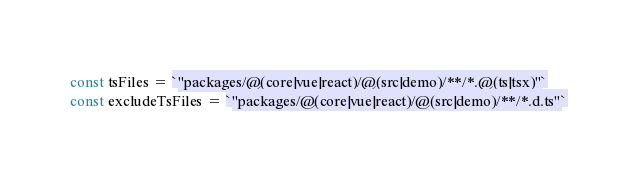<code> <loc_0><loc_0><loc_500><loc_500><_TypeScript_>const tsFiles = `"packages/@(core|vue|react)/@(src|demo)/**/*.@(ts|tsx)"`
const excludeTsFiles = `"packages/@(core|vue|react)/@(src|demo)/**/*.d.ts"`
</code> 